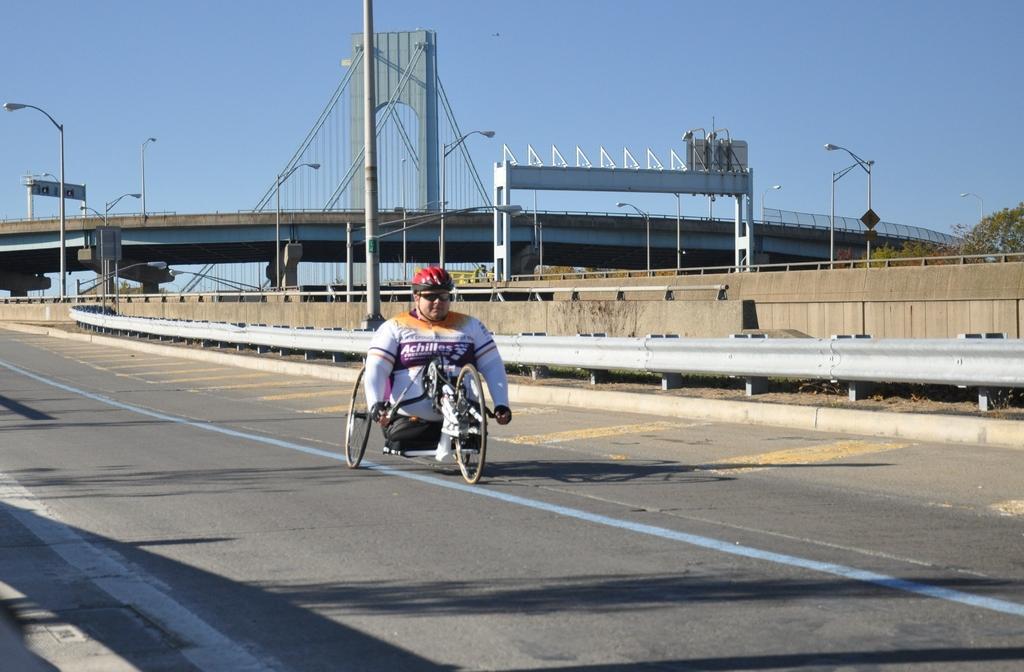Please provide a concise description of this image. In the middle of this image, there is a person, wearing a helmet and riding a tricycle on a road, on which there are yellow, blue and white color lines. In the background, there is a fence, there are poles, trees, a bridge and there is the blue sky. 